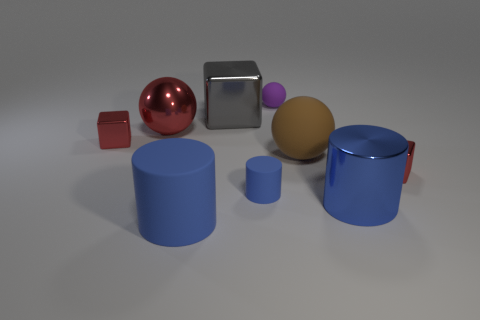What is the shape of the small object that is the same material as the tiny ball? The small object made of the same glossy material as the tiny reflective ball is a cylinder. This cylindrical shape is characterized by its circular base and height that's identical to the diameter of the tiny ball. 